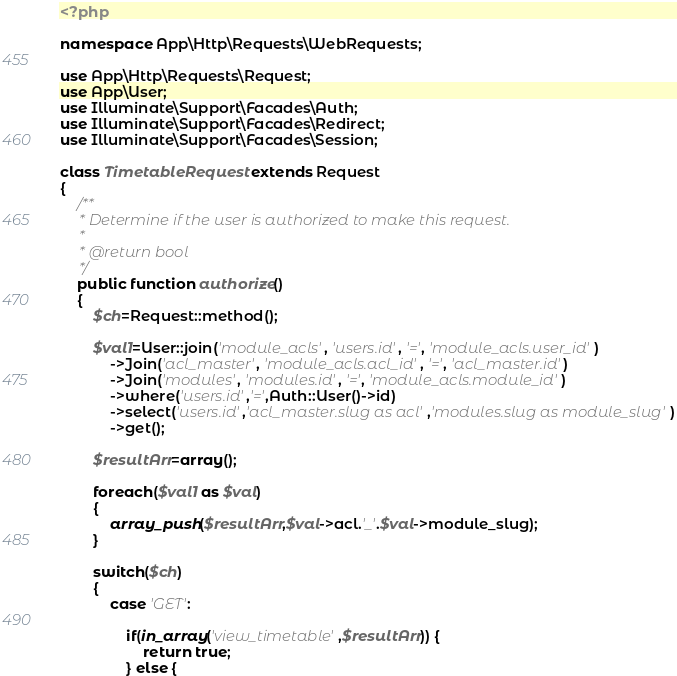Convert code to text. <code><loc_0><loc_0><loc_500><loc_500><_PHP_><?php

namespace App\Http\Requests\WebRequests;

use App\Http\Requests\Request;
use App\User;
use Illuminate\Support\Facades\Auth;
use Illuminate\Support\Facades\Redirect;
use Illuminate\Support\Facades\Session;

class TimetableRequest extends Request
{
    /**
     * Determine if the user is authorized to make this request.
     *
     * @return bool
     */
    public function authorize()
    {
        $ch=Request::method();

        $val1=User::join('module_acls', 'users.id', '=', 'module_acls.user_id')
            ->Join('acl_master', 'module_acls.acl_id', '=', 'acl_master.id')
            ->Join('modules', 'modules.id', '=', 'module_acls.module_id')
            ->where('users.id','=',Auth::User()->id)
            ->select('users.id','acl_master.slug as acl','modules.slug as module_slug')
            ->get();

        $resultArr=array();

        foreach($val1 as $val)
        {
            array_push($resultArr,$val->acl.'_'.$val->module_slug);
        }

        switch($ch)
        {
            case 'GET':

                if(in_array('view_timetable',$resultArr)) {
                    return true;
                } else {</code> 